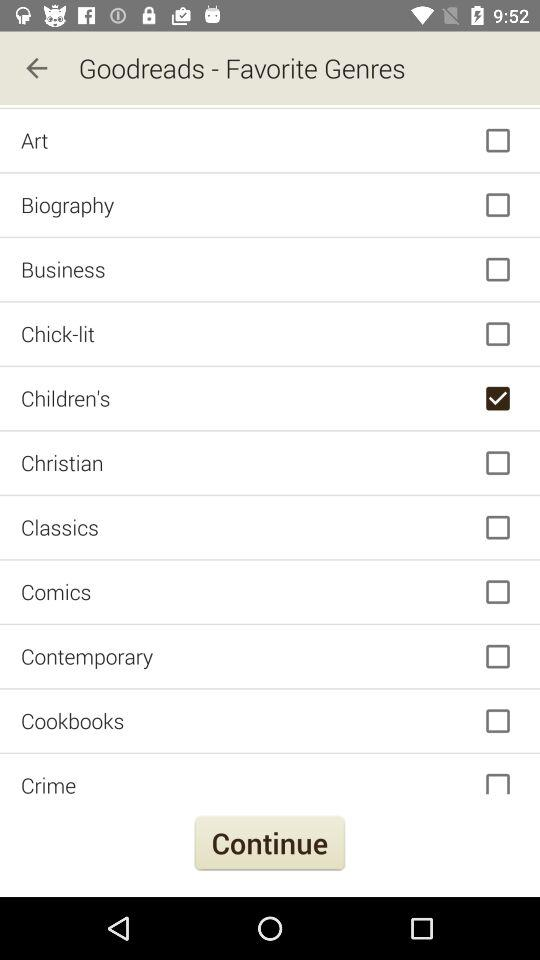What is the status of art? The status is "off". 